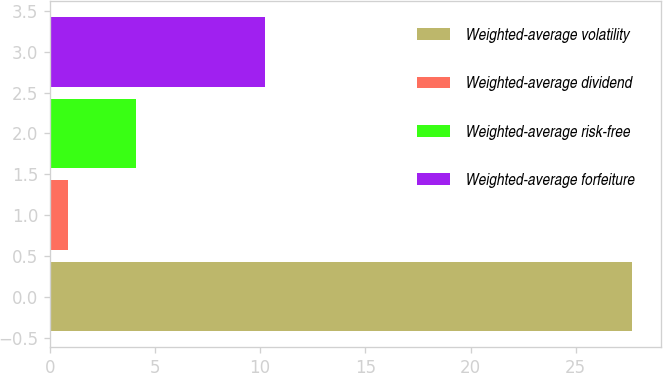Convert chart to OTSL. <chart><loc_0><loc_0><loc_500><loc_500><bar_chart><fcel>Weighted-average volatility<fcel>Weighted-average dividend<fcel>Weighted-average risk-free<fcel>Weighted-average forfeiture<nl><fcel>27.66<fcel>0.88<fcel>4.08<fcel>10.22<nl></chart> 